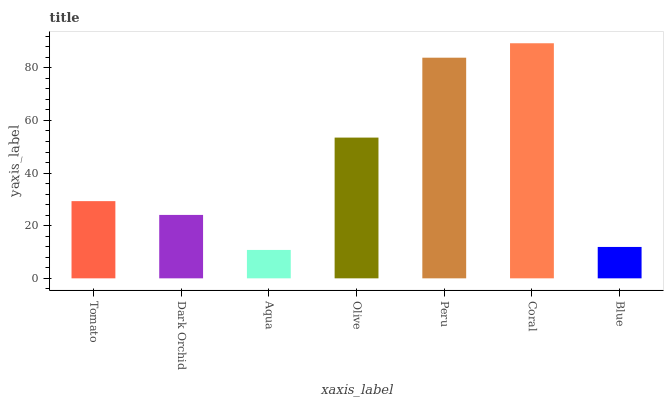Is Dark Orchid the minimum?
Answer yes or no. No. Is Dark Orchid the maximum?
Answer yes or no. No. Is Tomato greater than Dark Orchid?
Answer yes or no. Yes. Is Dark Orchid less than Tomato?
Answer yes or no. Yes. Is Dark Orchid greater than Tomato?
Answer yes or no. No. Is Tomato less than Dark Orchid?
Answer yes or no. No. Is Tomato the high median?
Answer yes or no. Yes. Is Tomato the low median?
Answer yes or no. Yes. Is Coral the high median?
Answer yes or no. No. Is Peru the low median?
Answer yes or no. No. 